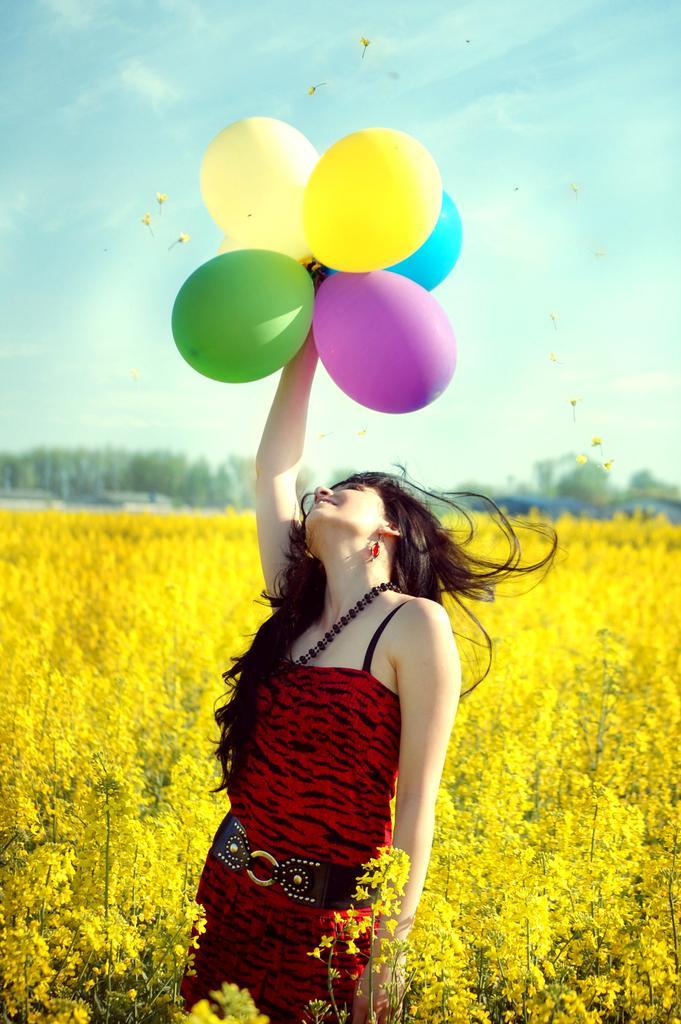In one or two sentences, can you explain what this image depicts? In this image we can see a woman standing holding some balloons. We can also see a group of plants with flowers, some trees, houses and the sky which looks cloudy. 